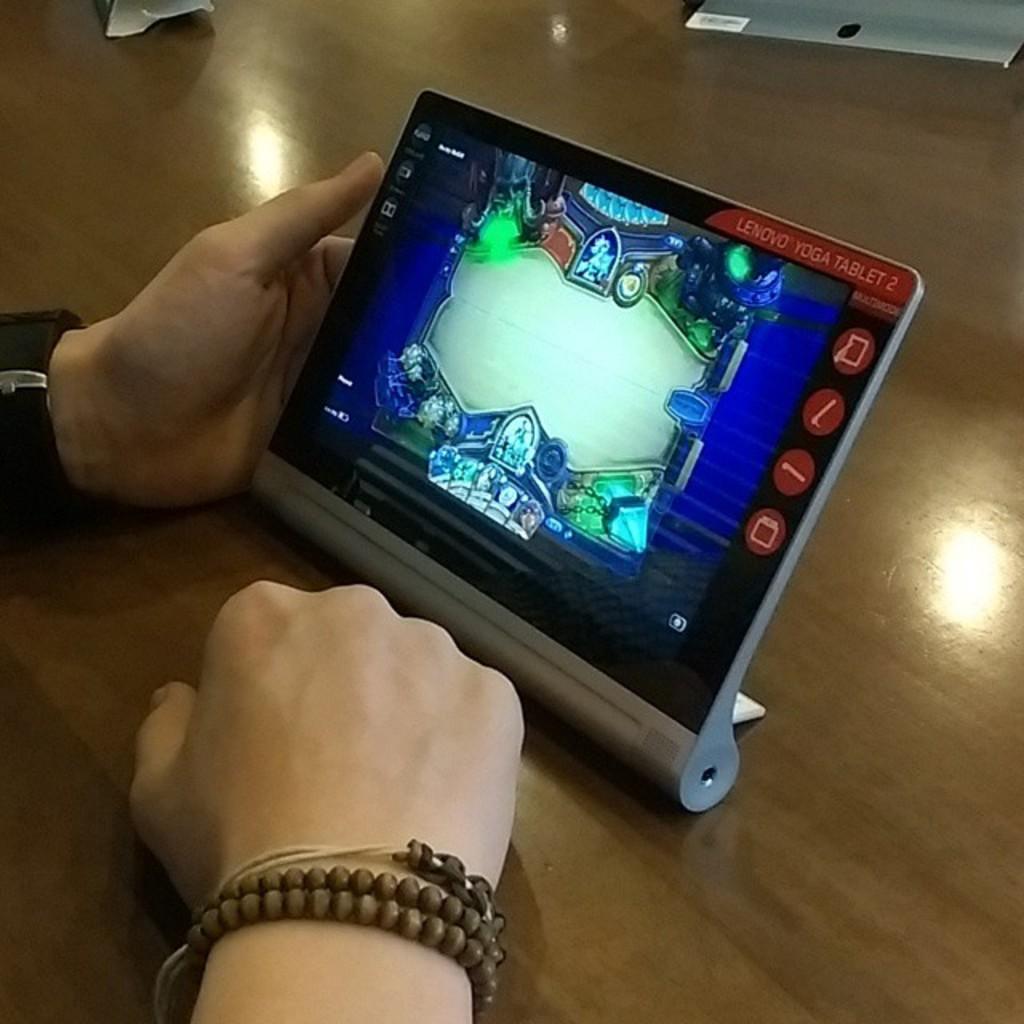Please provide a concise description of this image. In the picture we can find two hands on the table catching an i-pad and playing a game on one hand we can find a wrist watch. 